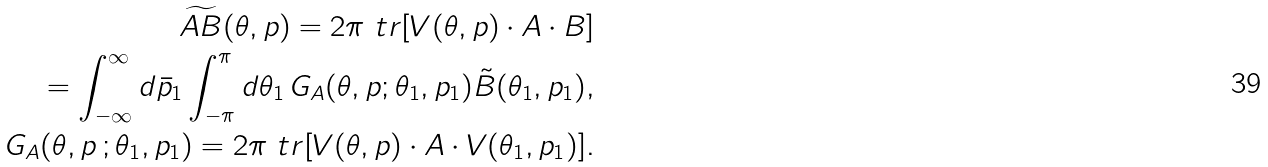<formula> <loc_0><loc_0><loc_500><loc_500>\widetilde { A B } ( \theta , p ) = 2 \pi \ t r [ V ( \theta , p ) \cdot A \cdot B ] \\ = \int _ { - \infty } ^ { \infty } d \bar { p } _ { 1 } \int _ { - \pi } ^ { \pi } d \theta _ { 1 } \, G _ { A } ( \theta , p ; \theta _ { 1 } , p _ { 1 } ) \tilde { B } ( \theta _ { 1 } , p _ { 1 } ) , \\ G _ { A } ( \theta , p \, ; \theta _ { 1 } , p _ { 1 } ) = 2 \pi \ t r [ V ( \theta , p ) \cdot A \cdot V ( \theta _ { 1 } , p _ { 1 } ) ] .</formula> 